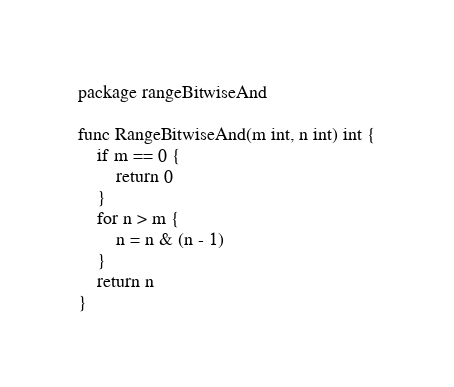Convert code to text. <code><loc_0><loc_0><loc_500><loc_500><_Go_>package rangeBitwiseAnd

func RangeBitwiseAnd(m int, n int) int {
	if m == 0 {
		return 0
	}
	for n > m {
		n = n & (n - 1)
	}
	return n
}
</code> 